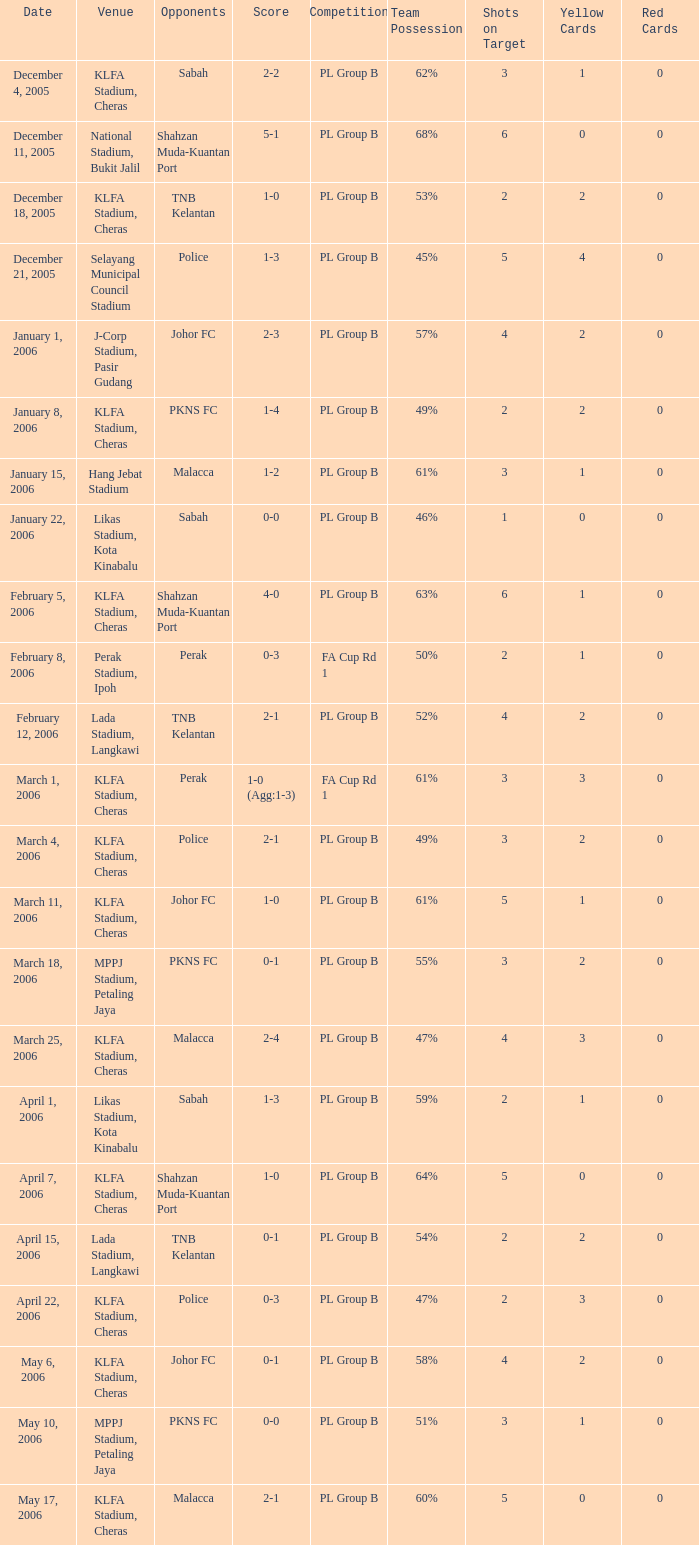Which Competition has a Score of 0-1, and Opponents of pkns fc? PL Group B. Would you be able to parse every entry in this table? {'header': ['Date', 'Venue', 'Opponents', 'Score', 'Competition', 'Team Possession', 'Shots on Target', 'Yellow Cards', 'Red Cards'], 'rows': [['December 4, 2005', 'KLFA Stadium, Cheras', 'Sabah', '2-2', 'PL Group B', '62%', '3', '1', '0'], ['December 11, 2005', 'National Stadium, Bukit Jalil', 'Shahzan Muda-Kuantan Port', '5-1', 'PL Group B', '68%', '6', '0', '0'], ['December 18, 2005', 'KLFA Stadium, Cheras', 'TNB Kelantan', '1-0', 'PL Group B', '53%', '2', '2', '0'], ['December 21, 2005', 'Selayang Municipal Council Stadium', 'Police', '1-3', 'PL Group B', '45%', '5', '4', '0'], ['January 1, 2006', 'J-Corp Stadium, Pasir Gudang', 'Johor FC', '2-3', 'PL Group B', '57%', '4', '2', '0'], ['January 8, 2006', 'KLFA Stadium, Cheras', 'PKNS FC', '1-4', 'PL Group B', '49%', '2', '2', '0'], ['January 15, 2006', 'Hang Jebat Stadium', 'Malacca', '1-2', 'PL Group B', '61%', '3', '1', '0'], ['January 22, 2006', 'Likas Stadium, Kota Kinabalu', 'Sabah', '0-0', 'PL Group B', '46%', '1', '0', '0'], ['February 5, 2006', 'KLFA Stadium, Cheras', 'Shahzan Muda-Kuantan Port', '4-0', 'PL Group B', '63%', '6', '1', '0'], ['February 8, 2006', 'Perak Stadium, Ipoh', 'Perak', '0-3', 'FA Cup Rd 1', '50%', '2', '1', '0'], ['February 12, 2006', 'Lada Stadium, Langkawi', 'TNB Kelantan', '2-1', 'PL Group B', '52%', '4', '2', '0'], ['March 1, 2006', 'KLFA Stadium, Cheras', 'Perak', '1-0 (Agg:1-3)', 'FA Cup Rd 1', '61%', '3', '3', '0'], ['March 4, 2006', 'KLFA Stadium, Cheras', 'Police', '2-1', 'PL Group B', '49%', '3', '2', '0'], ['March 11, 2006', 'KLFA Stadium, Cheras', 'Johor FC', '1-0', 'PL Group B', '61%', '5', '1', '0'], ['March 18, 2006', 'MPPJ Stadium, Petaling Jaya', 'PKNS FC', '0-1', 'PL Group B', '55%', '3', '2', '0'], ['March 25, 2006', 'KLFA Stadium, Cheras', 'Malacca', '2-4', 'PL Group B', '47%', '4', '3', '0'], ['April 1, 2006', 'Likas Stadium, Kota Kinabalu', 'Sabah', '1-3', 'PL Group B', '59%', '2', '1', '0'], ['April 7, 2006', 'KLFA Stadium, Cheras', 'Shahzan Muda-Kuantan Port', '1-0', 'PL Group B', '64%', '5', '0', '0'], ['April 15, 2006', 'Lada Stadium, Langkawi', 'TNB Kelantan', '0-1', 'PL Group B', '54%', '2', '2', '0'], ['April 22, 2006', 'KLFA Stadium, Cheras', 'Police', '0-3', 'PL Group B', '47%', '2', '3', '0'], ['May 6, 2006', 'KLFA Stadium, Cheras', 'Johor FC', '0-1', 'PL Group B', '58%', '4', '2', '0'], ['May 10, 2006', 'MPPJ Stadium, Petaling Jaya', 'PKNS FC', '0-0', 'PL Group B', '51%', '3', '1', '0'], ['May 17, 2006', 'KLFA Stadium, Cheras', 'Malacca', '2-1', 'PL Group B', '60%', '5', '0', '0']]} 